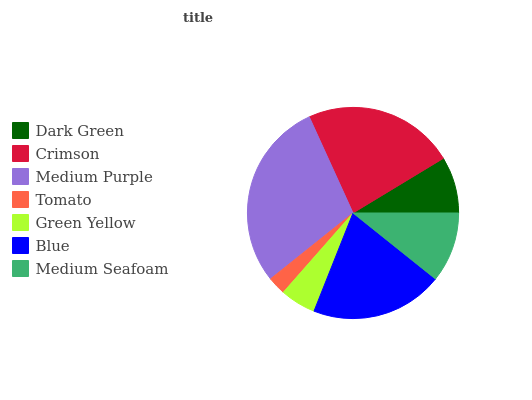Is Tomato the minimum?
Answer yes or no. Yes. Is Medium Purple the maximum?
Answer yes or no. Yes. Is Crimson the minimum?
Answer yes or no. No. Is Crimson the maximum?
Answer yes or no. No. Is Crimson greater than Dark Green?
Answer yes or no. Yes. Is Dark Green less than Crimson?
Answer yes or no. Yes. Is Dark Green greater than Crimson?
Answer yes or no. No. Is Crimson less than Dark Green?
Answer yes or no. No. Is Medium Seafoam the high median?
Answer yes or no. Yes. Is Medium Seafoam the low median?
Answer yes or no. Yes. Is Medium Purple the high median?
Answer yes or no. No. Is Tomato the low median?
Answer yes or no. No. 